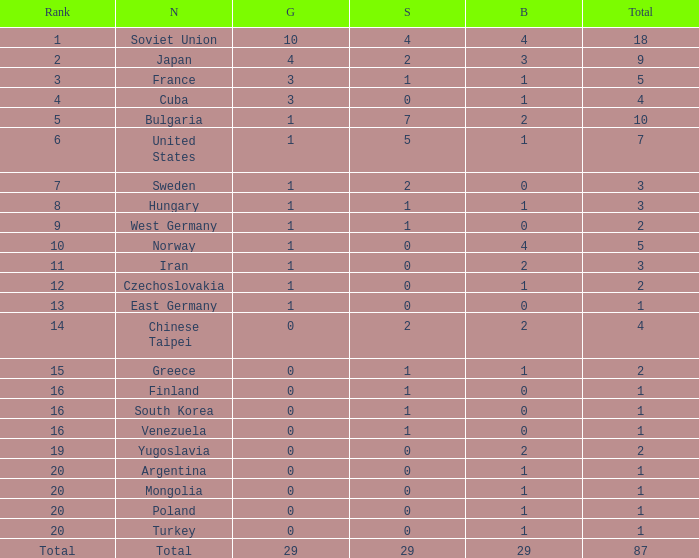What is the average number of bronze medals for total of all nations? 29.0. 